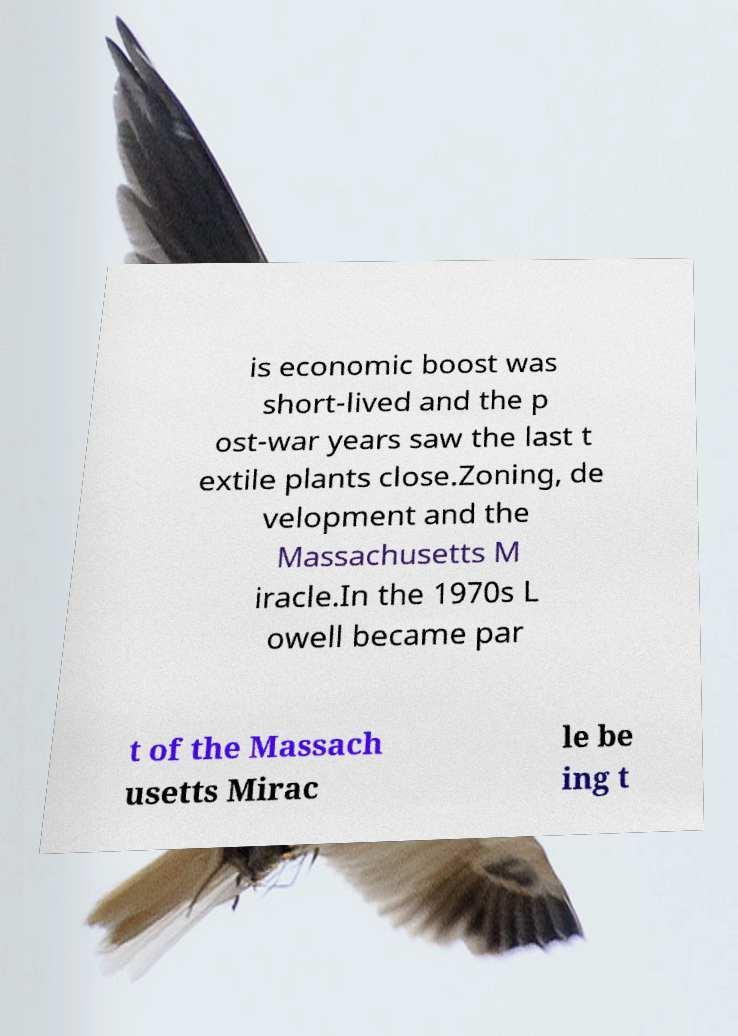Could you assist in decoding the text presented in this image and type it out clearly? is economic boost was short-lived and the p ost-war years saw the last t extile plants close.Zoning, de velopment and the Massachusetts M iracle.In the 1970s L owell became par t of the Massach usetts Mirac le be ing t 